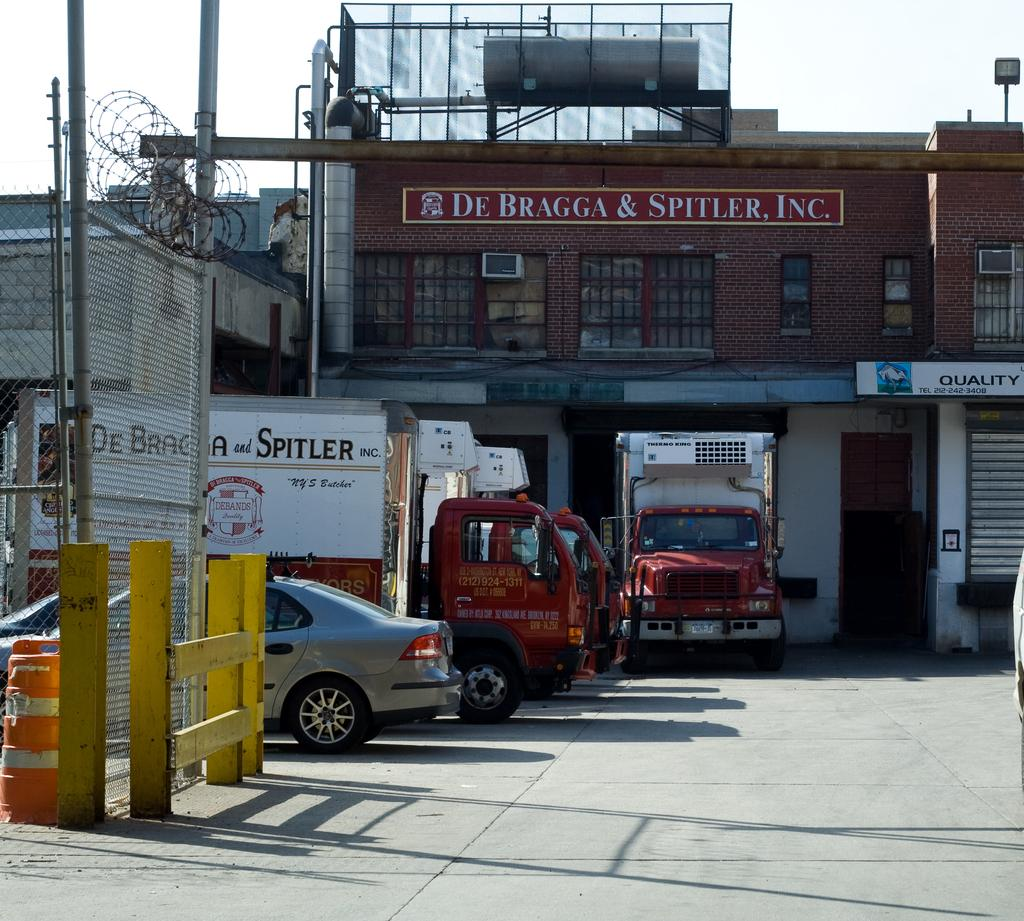<image>
Offer a succinct explanation of the picture presented. Some vehicles outside of a building, one of them has the word Spitler visible. 